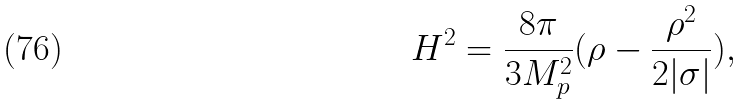Convert formula to latex. <formula><loc_0><loc_0><loc_500><loc_500>H ^ { 2 } = \frac { 8 \pi } { 3 M _ { p } ^ { 2 } } ( \rho - \frac { \rho ^ { 2 } } { 2 | \sigma | } ) ,</formula> 